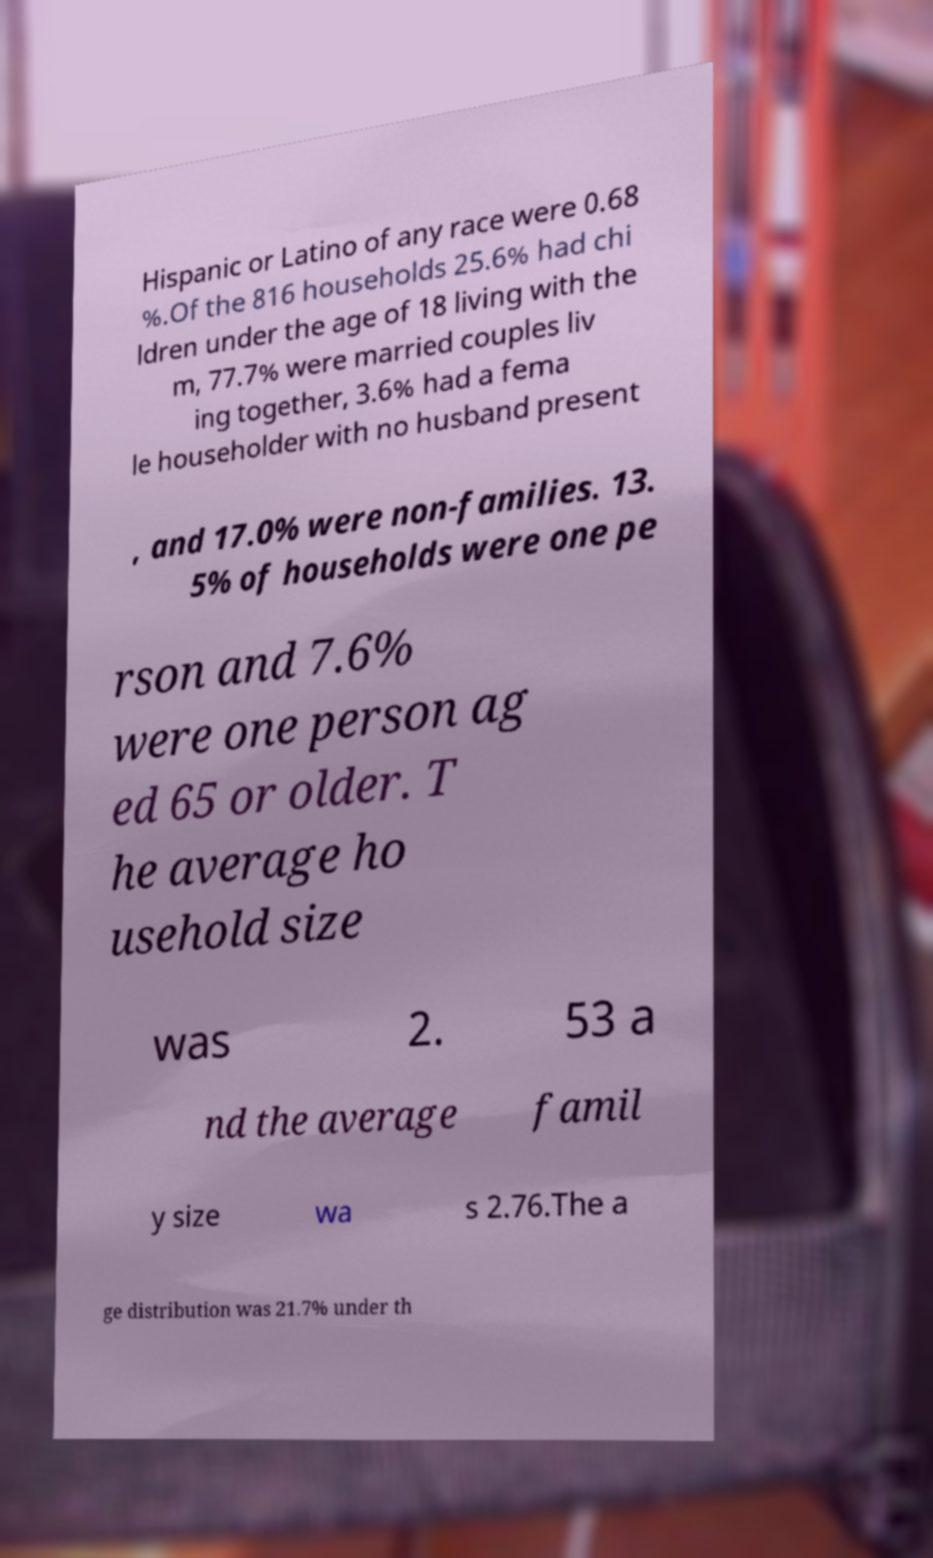Could you extract and type out the text from this image? Hispanic or Latino of any race were 0.68 %.Of the 816 households 25.6% had chi ldren under the age of 18 living with the m, 77.7% were married couples liv ing together, 3.6% had a fema le householder with no husband present , and 17.0% were non-families. 13. 5% of households were one pe rson and 7.6% were one person ag ed 65 or older. T he average ho usehold size was 2. 53 a nd the average famil y size wa s 2.76.The a ge distribution was 21.7% under th 